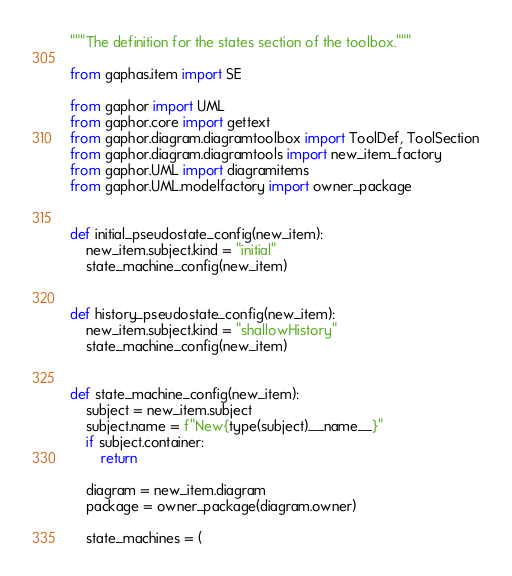<code> <loc_0><loc_0><loc_500><loc_500><_Python_>"""The definition for the states section of the toolbox."""

from gaphas.item import SE

from gaphor import UML
from gaphor.core import gettext
from gaphor.diagram.diagramtoolbox import ToolDef, ToolSection
from gaphor.diagram.diagramtools import new_item_factory
from gaphor.UML import diagramitems
from gaphor.UML.modelfactory import owner_package


def initial_pseudostate_config(new_item):
    new_item.subject.kind = "initial"
    state_machine_config(new_item)


def history_pseudostate_config(new_item):
    new_item.subject.kind = "shallowHistory"
    state_machine_config(new_item)


def state_machine_config(new_item):
    subject = new_item.subject
    subject.name = f"New{type(subject).__name__}"
    if subject.container:
        return

    diagram = new_item.diagram
    package = owner_package(diagram.owner)

    state_machines = (</code> 